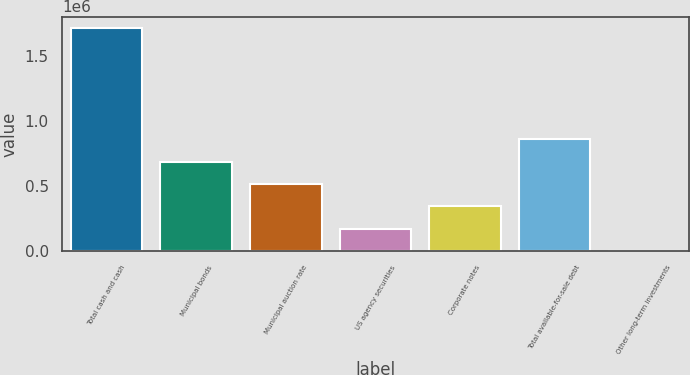Convert chart to OTSL. <chart><loc_0><loc_0><loc_500><loc_500><bar_chart><fcel>Total cash and cash<fcel>Municipal bonds<fcel>Municipal auction rate<fcel>US agency securities<fcel>Corporate notes<fcel>Total available-for-sale debt<fcel>Other long-term investments<nl><fcel>1.71413e+06<fcel>687719<fcel>516650<fcel>174514<fcel>345582<fcel>858788<fcel>3445<nl></chart> 